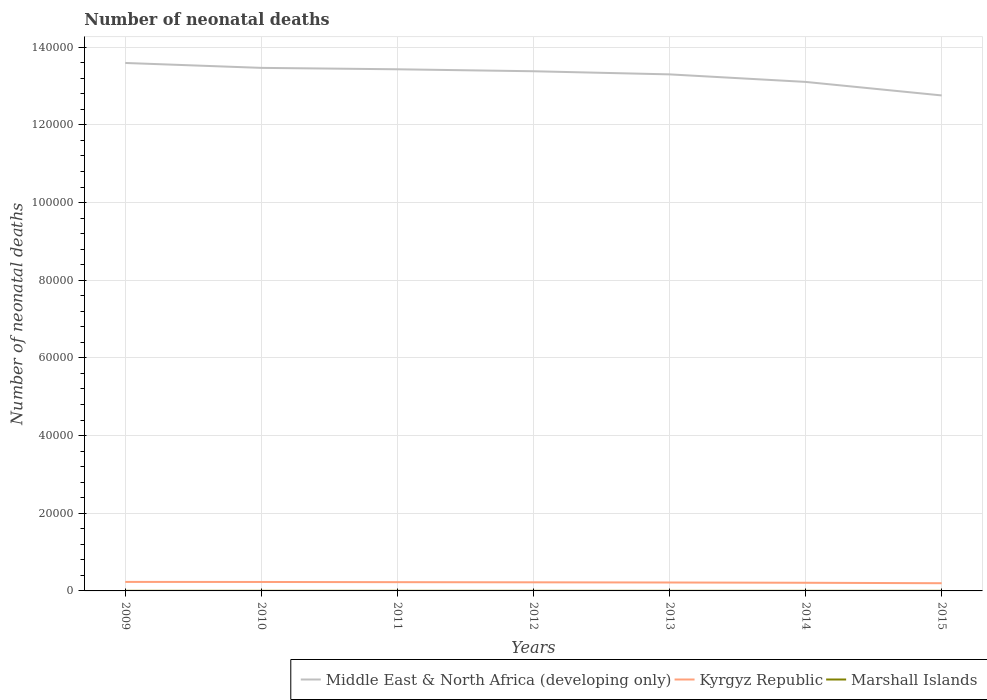In which year was the number of neonatal deaths in in Middle East & North Africa (developing only) maximum?
Ensure brevity in your answer.  2015. What is the total number of neonatal deaths in in Kyrgyz Republic in the graph?
Give a very brief answer. 70. What is the difference between the highest and the second highest number of neonatal deaths in in Kyrgyz Republic?
Your answer should be compact. 337. What is the difference between the highest and the lowest number of neonatal deaths in in Kyrgyz Republic?
Keep it short and to the point. 4. Is the number of neonatal deaths in in Kyrgyz Republic strictly greater than the number of neonatal deaths in in Marshall Islands over the years?
Your answer should be very brief. No. How many years are there in the graph?
Provide a short and direct response. 7. Does the graph contain any zero values?
Your response must be concise. No. Where does the legend appear in the graph?
Ensure brevity in your answer.  Bottom right. How many legend labels are there?
Your answer should be compact. 3. What is the title of the graph?
Make the answer very short. Number of neonatal deaths. What is the label or title of the Y-axis?
Provide a short and direct response. Number of neonatal deaths. What is the Number of neonatal deaths of Middle East & North Africa (developing only) in 2009?
Make the answer very short. 1.36e+05. What is the Number of neonatal deaths of Kyrgyz Republic in 2009?
Provide a succinct answer. 2322. What is the Number of neonatal deaths in Marshall Islands in 2009?
Keep it short and to the point. 29. What is the Number of neonatal deaths of Middle East & North Africa (developing only) in 2010?
Your response must be concise. 1.35e+05. What is the Number of neonatal deaths in Kyrgyz Republic in 2010?
Your answer should be compact. 2306. What is the Number of neonatal deaths of Middle East & North Africa (developing only) in 2011?
Your answer should be compact. 1.34e+05. What is the Number of neonatal deaths in Kyrgyz Republic in 2011?
Provide a short and direct response. 2257. What is the Number of neonatal deaths in Middle East & North Africa (developing only) in 2012?
Keep it short and to the point. 1.34e+05. What is the Number of neonatal deaths in Kyrgyz Republic in 2012?
Provide a short and direct response. 2217. What is the Number of neonatal deaths in Middle East & North Africa (developing only) in 2013?
Your response must be concise. 1.33e+05. What is the Number of neonatal deaths of Kyrgyz Republic in 2013?
Give a very brief answer. 2169. What is the Number of neonatal deaths in Marshall Islands in 2013?
Offer a terse response. 25. What is the Number of neonatal deaths of Middle East & North Africa (developing only) in 2014?
Your answer should be very brief. 1.31e+05. What is the Number of neonatal deaths of Kyrgyz Republic in 2014?
Ensure brevity in your answer.  2099. What is the Number of neonatal deaths in Middle East & North Africa (developing only) in 2015?
Keep it short and to the point. 1.28e+05. What is the Number of neonatal deaths in Kyrgyz Republic in 2015?
Provide a short and direct response. 1985. What is the Number of neonatal deaths in Marshall Islands in 2015?
Your answer should be compact. 23. Across all years, what is the maximum Number of neonatal deaths in Middle East & North Africa (developing only)?
Your response must be concise. 1.36e+05. Across all years, what is the maximum Number of neonatal deaths of Kyrgyz Republic?
Offer a very short reply. 2322. Across all years, what is the minimum Number of neonatal deaths of Middle East & North Africa (developing only)?
Make the answer very short. 1.28e+05. Across all years, what is the minimum Number of neonatal deaths in Kyrgyz Republic?
Keep it short and to the point. 1985. What is the total Number of neonatal deaths of Middle East & North Africa (developing only) in the graph?
Offer a very short reply. 9.30e+05. What is the total Number of neonatal deaths of Kyrgyz Republic in the graph?
Your response must be concise. 1.54e+04. What is the total Number of neonatal deaths of Marshall Islands in the graph?
Offer a very short reply. 182. What is the difference between the Number of neonatal deaths in Middle East & North Africa (developing only) in 2009 and that in 2010?
Make the answer very short. 1262. What is the difference between the Number of neonatal deaths in Kyrgyz Republic in 2009 and that in 2010?
Provide a short and direct response. 16. What is the difference between the Number of neonatal deaths in Middle East & North Africa (developing only) in 2009 and that in 2011?
Offer a terse response. 1625. What is the difference between the Number of neonatal deaths of Kyrgyz Republic in 2009 and that in 2011?
Keep it short and to the point. 65. What is the difference between the Number of neonatal deaths of Middle East & North Africa (developing only) in 2009 and that in 2012?
Offer a very short reply. 2132. What is the difference between the Number of neonatal deaths in Kyrgyz Republic in 2009 and that in 2012?
Ensure brevity in your answer.  105. What is the difference between the Number of neonatal deaths in Middle East & North Africa (developing only) in 2009 and that in 2013?
Keep it short and to the point. 2936. What is the difference between the Number of neonatal deaths in Kyrgyz Republic in 2009 and that in 2013?
Provide a short and direct response. 153. What is the difference between the Number of neonatal deaths of Marshall Islands in 2009 and that in 2013?
Keep it short and to the point. 4. What is the difference between the Number of neonatal deaths in Middle East & North Africa (developing only) in 2009 and that in 2014?
Keep it short and to the point. 4877. What is the difference between the Number of neonatal deaths of Kyrgyz Republic in 2009 and that in 2014?
Your answer should be compact. 223. What is the difference between the Number of neonatal deaths in Middle East & North Africa (developing only) in 2009 and that in 2015?
Your answer should be compact. 8357. What is the difference between the Number of neonatal deaths of Kyrgyz Republic in 2009 and that in 2015?
Give a very brief answer. 337. What is the difference between the Number of neonatal deaths of Marshall Islands in 2009 and that in 2015?
Your answer should be compact. 6. What is the difference between the Number of neonatal deaths in Middle East & North Africa (developing only) in 2010 and that in 2011?
Your response must be concise. 363. What is the difference between the Number of neonatal deaths in Marshall Islands in 2010 and that in 2011?
Your response must be concise. 1. What is the difference between the Number of neonatal deaths of Middle East & North Africa (developing only) in 2010 and that in 2012?
Your answer should be very brief. 870. What is the difference between the Number of neonatal deaths in Kyrgyz Republic in 2010 and that in 2012?
Your answer should be compact. 89. What is the difference between the Number of neonatal deaths of Middle East & North Africa (developing only) in 2010 and that in 2013?
Provide a succinct answer. 1674. What is the difference between the Number of neonatal deaths in Kyrgyz Republic in 2010 and that in 2013?
Your response must be concise. 137. What is the difference between the Number of neonatal deaths of Middle East & North Africa (developing only) in 2010 and that in 2014?
Offer a terse response. 3615. What is the difference between the Number of neonatal deaths of Kyrgyz Republic in 2010 and that in 2014?
Make the answer very short. 207. What is the difference between the Number of neonatal deaths of Marshall Islands in 2010 and that in 2014?
Give a very brief answer. 4. What is the difference between the Number of neonatal deaths in Middle East & North Africa (developing only) in 2010 and that in 2015?
Your response must be concise. 7095. What is the difference between the Number of neonatal deaths in Kyrgyz Republic in 2010 and that in 2015?
Your answer should be compact. 321. What is the difference between the Number of neonatal deaths in Marshall Islands in 2010 and that in 2015?
Offer a terse response. 5. What is the difference between the Number of neonatal deaths of Middle East & North Africa (developing only) in 2011 and that in 2012?
Your response must be concise. 507. What is the difference between the Number of neonatal deaths in Kyrgyz Republic in 2011 and that in 2012?
Provide a short and direct response. 40. What is the difference between the Number of neonatal deaths in Middle East & North Africa (developing only) in 2011 and that in 2013?
Give a very brief answer. 1311. What is the difference between the Number of neonatal deaths of Marshall Islands in 2011 and that in 2013?
Provide a short and direct response. 2. What is the difference between the Number of neonatal deaths in Middle East & North Africa (developing only) in 2011 and that in 2014?
Give a very brief answer. 3252. What is the difference between the Number of neonatal deaths in Kyrgyz Republic in 2011 and that in 2014?
Offer a terse response. 158. What is the difference between the Number of neonatal deaths of Marshall Islands in 2011 and that in 2014?
Provide a short and direct response. 3. What is the difference between the Number of neonatal deaths in Middle East & North Africa (developing only) in 2011 and that in 2015?
Offer a terse response. 6732. What is the difference between the Number of neonatal deaths of Kyrgyz Republic in 2011 and that in 2015?
Your answer should be very brief. 272. What is the difference between the Number of neonatal deaths of Middle East & North Africa (developing only) in 2012 and that in 2013?
Ensure brevity in your answer.  804. What is the difference between the Number of neonatal deaths in Kyrgyz Republic in 2012 and that in 2013?
Your answer should be compact. 48. What is the difference between the Number of neonatal deaths of Marshall Islands in 2012 and that in 2013?
Provide a short and direct response. 1. What is the difference between the Number of neonatal deaths of Middle East & North Africa (developing only) in 2012 and that in 2014?
Ensure brevity in your answer.  2745. What is the difference between the Number of neonatal deaths of Kyrgyz Republic in 2012 and that in 2014?
Your response must be concise. 118. What is the difference between the Number of neonatal deaths of Marshall Islands in 2012 and that in 2014?
Ensure brevity in your answer.  2. What is the difference between the Number of neonatal deaths of Middle East & North Africa (developing only) in 2012 and that in 2015?
Give a very brief answer. 6225. What is the difference between the Number of neonatal deaths in Kyrgyz Republic in 2012 and that in 2015?
Offer a terse response. 232. What is the difference between the Number of neonatal deaths in Middle East & North Africa (developing only) in 2013 and that in 2014?
Offer a very short reply. 1941. What is the difference between the Number of neonatal deaths in Kyrgyz Republic in 2013 and that in 2014?
Keep it short and to the point. 70. What is the difference between the Number of neonatal deaths in Marshall Islands in 2013 and that in 2014?
Give a very brief answer. 1. What is the difference between the Number of neonatal deaths in Middle East & North Africa (developing only) in 2013 and that in 2015?
Provide a succinct answer. 5421. What is the difference between the Number of neonatal deaths in Kyrgyz Republic in 2013 and that in 2015?
Provide a succinct answer. 184. What is the difference between the Number of neonatal deaths in Middle East & North Africa (developing only) in 2014 and that in 2015?
Keep it short and to the point. 3480. What is the difference between the Number of neonatal deaths in Kyrgyz Republic in 2014 and that in 2015?
Your response must be concise. 114. What is the difference between the Number of neonatal deaths in Middle East & North Africa (developing only) in 2009 and the Number of neonatal deaths in Kyrgyz Republic in 2010?
Your response must be concise. 1.34e+05. What is the difference between the Number of neonatal deaths in Middle East & North Africa (developing only) in 2009 and the Number of neonatal deaths in Marshall Islands in 2010?
Give a very brief answer. 1.36e+05. What is the difference between the Number of neonatal deaths in Kyrgyz Republic in 2009 and the Number of neonatal deaths in Marshall Islands in 2010?
Your answer should be very brief. 2294. What is the difference between the Number of neonatal deaths of Middle East & North Africa (developing only) in 2009 and the Number of neonatal deaths of Kyrgyz Republic in 2011?
Your response must be concise. 1.34e+05. What is the difference between the Number of neonatal deaths in Middle East & North Africa (developing only) in 2009 and the Number of neonatal deaths in Marshall Islands in 2011?
Make the answer very short. 1.36e+05. What is the difference between the Number of neonatal deaths of Kyrgyz Republic in 2009 and the Number of neonatal deaths of Marshall Islands in 2011?
Offer a very short reply. 2295. What is the difference between the Number of neonatal deaths of Middle East & North Africa (developing only) in 2009 and the Number of neonatal deaths of Kyrgyz Republic in 2012?
Your answer should be very brief. 1.34e+05. What is the difference between the Number of neonatal deaths of Middle East & North Africa (developing only) in 2009 and the Number of neonatal deaths of Marshall Islands in 2012?
Make the answer very short. 1.36e+05. What is the difference between the Number of neonatal deaths of Kyrgyz Republic in 2009 and the Number of neonatal deaths of Marshall Islands in 2012?
Ensure brevity in your answer.  2296. What is the difference between the Number of neonatal deaths in Middle East & North Africa (developing only) in 2009 and the Number of neonatal deaths in Kyrgyz Republic in 2013?
Offer a very short reply. 1.34e+05. What is the difference between the Number of neonatal deaths of Middle East & North Africa (developing only) in 2009 and the Number of neonatal deaths of Marshall Islands in 2013?
Offer a terse response. 1.36e+05. What is the difference between the Number of neonatal deaths in Kyrgyz Republic in 2009 and the Number of neonatal deaths in Marshall Islands in 2013?
Your response must be concise. 2297. What is the difference between the Number of neonatal deaths of Middle East & North Africa (developing only) in 2009 and the Number of neonatal deaths of Kyrgyz Republic in 2014?
Provide a succinct answer. 1.34e+05. What is the difference between the Number of neonatal deaths in Middle East & North Africa (developing only) in 2009 and the Number of neonatal deaths in Marshall Islands in 2014?
Your answer should be very brief. 1.36e+05. What is the difference between the Number of neonatal deaths in Kyrgyz Republic in 2009 and the Number of neonatal deaths in Marshall Islands in 2014?
Your response must be concise. 2298. What is the difference between the Number of neonatal deaths in Middle East & North Africa (developing only) in 2009 and the Number of neonatal deaths in Kyrgyz Republic in 2015?
Your response must be concise. 1.34e+05. What is the difference between the Number of neonatal deaths of Middle East & North Africa (developing only) in 2009 and the Number of neonatal deaths of Marshall Islands in 2015?
Make the answer very short. 1.36e+05. What is the difference between the Number of neonatal deaths of Kyrgyz Republic in 2009 and the Number of neonatal deaths of Marshall Islands in 2015?
Offer a terse response. 2299. What is the difference between the Number of neonatal deaths in Middle East & North Africa (developing only) in 2010 and the Number of neonatal deaths in Kyrgyz Republic in 2011?
Make the answer very short. 1.32e+05. What is the difference between the Number of neonatal deaths of Middle East & North Africa (developing only) in 2010 and the Number of neonatal deaths of Marshall Islands in 2011?
Offer a very short reply. 1.35e+05. What is the difference between the Number of neonatal deaths of Kyrgyz Republic in 2010 and the Number of neonatal deaths of Marshall Islands in 2011?
Your answer should be compact. 2279. What is the difference between the Number of neonatal deaths in Middle East & North Africa (developing only) in 2010 and the Number of neonatal deaths in Kyrgyz Republic in 2012?
Provide a short and direct response. 1.32e+05. What is the difference between the Number of neonatal deaths of Middle East & North Africa (developing only) in 2010 and the Number of neonatal deaths of Marshall Islands in 2012?
Ensure brevity in your answer.  1.35e+05. What is the difference between the Number of neonatal deaths of Kyrgyz Republic in 2010 and the Number of neonatal deaths of Marshall Islands in 2012?
Keep it short and to the point. 2280. What is the difference between the Number of neonatal deaths in Middle East & North Africa (developing only) in 2010 and the Number of neonatal deaths in Kyrgyz Republic in 2013?
Give a very brief answer. 1.33e+05. What is the difference between the Number of neonatal deaths of Middle East & North Africa (developing only) in 2010 and the Number of neonatal deaths of Marshall Islands in 2013?
Your answer should be very brief. 1.35e+05. What is the difference between the Number of neonatal deaths of Kyrgyz Republic in 2010 and the Number of neonatal deaths of Marshall Islands in 2013?
Ensure brevity in your answer.  2281. What is the difference between the Number of neonatal deaths in Middle East & North Africa (developing only) in 2010 and the Number of neonatal deaths in Kyrgyz Republic in 2014?
Keep it short and to the point. 1.33e+05. What is the difference between the Number of neonatal deaths of Middle East & North Africa (developing only) in 2010 and the Number of neonatal deaths of Marshall Islands in 2014?
Offer a terse response. 1.35e+05. What is the difference between the Number of neonatal deaths of Kyrgyz Republic in 2010 and the Number of neonatal deaths of Marshall Islands in 2014?
Provide a short and direct response. 2282. What is the difference between the Number of neonatal deaths of Middle East & North Africa (developing only) in 2010 and the Number of neonatal deaths of Kyrgyz Republic in 2015?
Your response must be concise. 1.33e+05. What is the difference between the Number of neonatal deaths in Middle East & North Africa (developing only) in 2010 and the Number of neonatal deaths in Marshall Islands in 2015?
Your response must be concise. 1.35e+05. What is the difference between the Number of neonatal deaths in Kyrgyz Republic in 2010 and the Number of neonatal deaths in Marshall Islands in 2015?
Ensure brevity in your answer.  2283. What is the difference between the Number of neonatal deaths of Middle East & North Africa (developing only) in 2011 and the Number of neonatal deaths of Kyrgyz Republic in 2012?
Your response must be concise. 1.32e+05. What is the difference between the Number of neonatal deaths of Middle East & North Africa (developing only) in 2011 and the Number of neonatal deaths of Marshall Islands in 2012?
Ensure brevity in your answer.  1.34e+05. What is the difference between the Number of neonatal deaths in Kyrgyz Republic in 2011 and the Number of neonatal deaths in Marshall Islands in 2012?
Offer a very short reply. 2231. What is the difference between the Number of neonatal deaths in Middle East & North Africa (developing only) in 2011 and the Number of neonatal deaths in Kyrgyz Republic in 2013?
Give a very brief answer. 1.32e+05. What is the difference between the Number of neonatal deaths of Middle East & North Africa (developing only) in 2011 and the Number of neonatal deaths of Marshall Islands in 2013?
Your answer should be compact. 1.34e+05. What is the difference between the Number of neonatal deaths in Kyrgyz Republic in 2011 and the Number of neonatal deaths in Marshall Islands in 2013?
Offer a terse response. 2232. What is the difference between the Number of neonatal deaths of Middle East & North Africa (developing only) in 2011 and the Number of neonatal deaths of Kyrgyz Republic in 2014?
Offer a very short reply. 1.32e+05. What is the difference between the Number of neonatal deaths in Middle East & North Africa (developing only) in 2011 and the Number of neonatal deaths in Marshall Islands in 2014?
Keep it short and to the point. 1.34e+05. What is the difference between the Number of neonatal deaths of Kyrgyz Republic in 2011 and the Number of neonatal deaths of Marshall Islands in 2014?
Offer a terse response. 2233. What is the difference between the Number of neonatal deaths in Middle East & North Africa (developing only) in 2011 and the Number of neonatal deaths in Kyrgyz Republic in 2015?
Ensure brevity in your answer.  1.32e+05. What is the difference between the Number of neonatal deaths of Middle East & North Africa (developing only) in 2011 and the Number of neonatal deaths of Marshall Islands in 2015?
Ensure brevity in your answer.  1.34e+05. What is the difference between the Number of neonatal deaths in Kyrgyz Republic in 2011 and the Number of neonatal deaths in Marshall Islands in 2015?
Your response must be concise. 2234. What is the difference between the Number of neonatal deaths in Middle East & North Africa (developing only) in 2012 and the Number of neonatal deaths in Kyrgyz Republic in 2013?
Keep it short and to the point. 1.32e+05. What is the difference between the Number of neonatal deaths in Middle East & North Africa (developing only) in 2012 and the Number of neonatal deaths in Marshall Islands in 2013?
Offer a terse response. 1.34e+05. What is the difference between the Number of neonatal deaths in Kyrgyz Republic in 2012 and the Number of neonatal deaths in Marshall Islands in 2013?
Offer a very short reply. 2192. What is the difference between the Number of neonatal deaths of Middle East & North Africa (developing only) in 2012 and the Number of neonatal deaths of Kyrgyz Republic in 2014?
Your response must be concise. 1.32e+05. What is the difference between the Number of neonatal deaths in Middle East & North Africa (developing only) in 2012 and the Number of neonatal deaths in Marshall Islands in 2014?
Your response must be concise. 1.34e+05. What is the difference between the Number of neonatal deaths of Kyrgyz Republic in 2012 and the Number of neonatal deaths of Marshall Islands in 2014?
Your answer should be compact. 2193. What is the difference between the Number of neonatal deaths in Middle East & North Africa (developing only) in 2012 and the Number of neonatal deaths in Kyrgyz Republic in 2015?
Your response must be concise. 1.32e+05. What is the difference between the Number of neonatal deaths of Middle East & North Africa (developing only) in 2012 and the Number of neonatal deaths of Marshall Islands in 2015?
Your answer should be very brief. 1.34e+05. What is the difference between the Number of neonatal deaths in Kyrgyz Republic in 2012 and the Number of neonatal deaths in Marshall Islands in 2015?
Keep it short and to the point. 2194. What is the difference between the Number of neonatal deaths of Middle East & North Africa (developing only) in 2013 and the Number of neonatal deaths of Kyrgyz Republic in 2014?
Ensure brevity in your answer.  1.31e+05. What is the difference between the Number of neonatal deaths in Middle East & North Africa (developing only) in 2013 and the Number of neonatal deaths in Marshall Islands in 2014?
Your answer should be compact. 1.33e+05. What is the difference between the Number of neonatal deaths in Kyrgyz Republic in 2013 and the Number of neonatal deaths in Marshall Islands in 2014?
Keep it short and to the point. 2145. What is the difference between the Number of neonatal deaths in Middle East & North Africa (developing only) in 2013 and the Number of neonatal deaths in Kyrgyz Republic in 2015?
Offer a very short reply. 1.31e+05. What is the difference between the Number of neonatal deaths in Middle East & North Africa (developing only) in 2013 and the Number of neonatal deaths in Marshall Islands in 2015?
Make the answer very short. 1.33e+05. What is the difference between the Number of neonatal deaths in Kyrgyz Republic in 2013 and the Number of neonatal deaths in Marshall Islands in 2015?
Provide a short and direct response. 2146. What is the difference between the Number of neonatal deaths of Middle East & North Africa (developing only) in 2014 and the Number of neonatal deaths of Kyrgyz Republic in 2015?
Your answer should be compact. 1.29e+05. What is the difference between the Number of neonatal deaths of Middle East & North Africa (developing only) in 2014 and the Number of neonatal deaths of Marshall Islands in 2015?
Offer a very short reply. 1.31e+05. What is the difference between the Number of neonatal deaths in Kyrgyz Republic in 2014 and the Number of neonatal deaths in Marshall Islands in 2015?
Provide a succinct answer. 2076. What is the average Number of neonatal deaths of Middle East & North Africa (developing only) per year?
Provide a succinct answer. 1.33e+05. What is the average Number of neonatal deaths of Kyrgyz Republic per year?
Provide a succinct answer. 2193.57. In the year 2009, what is the difference between the Number of neonatal deaths in Middle East & North Africa (developing only) and Number of neonatal deaths in Kyrgyz Republic?
Give a very brief answer. 1.34e+05. In the year 2009, what is the difference between the Number of neonatal deaths in Middle East & North Africa (developing only) and Number of neonatal deaths in Marshall Islands?
Keep it short and to the point. 1.36e+05. In the year 2009, what is the difference between the Number of neonatal deaths of Kyrgyz Republic and Number of neonatal deaths of Marshall Islands?
Give a very brief answer. 2293. In the year 2010, what is the difference between the Number of neonatal deaths of Middle East & North Africa (developing only) and Number of neonatal deaths of Kyrgyz Republic?
Give a very brief answer. 1.32e+05. In the year 2010, what is the difference between the Number of neonatal deaths of Middle East & North Africa (developing only) and Number of neonatal deaths of Marshall Islands?
Make the answer very short. 1.35e+05. In the year 2010, what is the difference between the Number of neonatal deaths of Kyrgyz Republic and Number of neonatal deaths of Marshall Islands?
Your response must be concise. 2278. In the year 2011, what is the difference between the Number of neonatal deaths in Middle East & North Africa (developing only) and Number of neonatal deaths in Kyrgyz Republic?
Provide a succinct answer. 1.32e+05. In the year 2011, what is the difference between the Number of neonatal deaths of Middle East & North Africa (developing only) and Number of neonatal deaths of Marshall Islands?
Make the answer very short. 1.34e+05. In the year 2011, what is the difference between the Number of neonatal deaths of Kyrgyz Republic and Number of neonatal deaths of Marshall Islands?
Offer a terse response. 2230. In the year 2012, what is the difference between the Number of neonatal deaths in Middle East & North Africa (developing only) and Number of neonatal deaths in Kyrgyz Republic?
Ensure brevity in your answer.  1.32e+05. In the year 2012, what is the difference between the Number of neonatal deaths of Middle East & North Africa (developing only) and Number of neonatal deaths of Marshall Islands?
Give a very brief answer. 1.34e+05. In the year 2012, what is the difference between the Number of neonatal deaths of Kyrgyz Republic and Number of neonatal deaths of Marshall Islands?
Provide a short and direct response. 2191. In the year 2013, what is the difference between the Number of neonatal deaths of Middle East & North Africa (developing only) and Number of neonatal deaths of Kyrgyz Republic?
Your answer should be compact. 1.31e+05. In the year 2013, what is the difference between the Number of neonatal deaths in Middle East & North Africa (developing only) and Number of neonatal deaths in Marshall Islands?
Keep it short and to the point. 1.33e+05. In the year 2013, what is the difference between the Number of neonatal deaths of Kyrgyz Republic and Number of neonatal deaths of Marshall Islands?
Ensure brevity in your answer.  2144. In the year 2014, what is the difference between the Number of neonatal deaths in Middle East & North Africa (developing only) and Number of neonatal deaths in Kyrgyz Republic?
Provide a short and direct response. 1.29e+05. In the year 2014, what is the difference between the Number of neonatal deaths in Middle East & North Africa (developing only) and Number of neonatal deaths in Marshall Islands?
Provide a succinct answer. 1.31e+05. In the year 2014, what is the difference between the Number of neonatal deaths of Kyrgyz Republic and Number of neonatal deaths of Marshall Islands?
Provide a short and direct response. 2075. In the year 2015, what is the difference between the Number of neonatal deaths in Middle East & North Africa (developing only) and Number of neonatal deaths in Kyrgyz Republic?
Make the answer very short. 1.26e+05. In the year 2015, what is the difference between the Number of neonatal deaths in Middle East & North Africa (developing only) and Number of neonatal deaths in Marshall Islands?
Provide a succinct answer. 1.28e+05. In the year 2015, what is the difference between the Number of neonatal deaths of Kyrgyz Republic and Number of neonatal deaths of Marshall Islands?
Provide a short and direct response. 1962. What is the ratio of the Number of neonatal deaths in Middle East & North Africa (developing only) in 2009 to that in 2010?
Provide a succinct answer. 1.01. What is the ratio of the Number of neonatal deaths of Marshall Islands in 2009 to that in 2010?
Offer a very short reply. 1.04. What is the ratio of the Number of neonatal deaths in Middle East & North Africa (developing only) in 2009 to that in 2011?
Make the answer very short. 1.01. What is the ratio of the Number of neonatal deaths in Kyrgyz Republic in 2009 to that in 2011?
Offer a terse response. 1.03. What is the ratio of the Number of neonatal deaths in Marshall Islands in 2009 to that in 2011?
Your response must be concise. 1.07. What is the ratio of the Number of neonatal deaths in Middle East & North Africa (developing only) in 2009 to that in 2012?
Keep it short and to the point. 1.02. What is the ratio of the Number of neonatal deaths of Kyrgyz Republic in 2009 to that in 2012?
Keep it short and to the point. 1.05. What is the ratio of the Number of neonatal deaths in Marshall Islands in 2009 to that in 2012?
Make the answer very short. 1.12. What is the ratio of the Number of neonatal deaths in Middle East & North Africa (developing only) in 2009 to that in 2013?
Give a very brief answer. 1.02. What is the ratio of the Number of neonatal deaths in Kyrgyz Republic in 2009 to that in 2013?
Provide a short and direct response. 1.07. What is the ratio of the Number of neonatal deaths in Marshall Islands in 2009 to that in 2013?
Your answer should be compact. 1.16. What is the ratio of the Number of neonatal deaths of Middle East & North Africa (developing only) in 2009 to that in 2014?
Keep it short and to the point. 1.04. What is the ratio of the Number of neonatal deaths in Kyrgyz Republic in 2009 to that in 2014?
Your response must be concise. 1.11. What is the ratio of the Number of neonatal deaths in Marshall Islands in 2009 to that in 2014?
Give a very brief answer. 1.21. What is the ratio of the Number of neonatal deaths in Middle East & North Africa (developing only) in 2009 to that in 2015?
Provide a short and direct response. 1.07. What is the ratio of the Number of neonatal deaths in Kyrgyz Republic in 2009 to that in 2015?
Give a very brief answer. 1.17. What is the ratio of the Number of neonatal deaths in Marshall Islands in 2009 to that in 2015?
Ensure brevity in your answer.  1.26. What is the ratio of the Number of neonatal deaths of Middle East & North Africa (developing only) in 2010 to that in 2011?
Your response must be concise. 1. What is the ratio of the Number of neonatal deaths in Kyrgyz Republic in 2010 to that in 2011?
Make the answer very short. 1.02. What is the ratio of the Number of neonatal deaths in Kyrgyz Republic in 2010 to that in 2012?
Offer a very short reply. 1.04. What is the ratio of the Number of neonatal deaths of Marshall Islands in 2010 to that in 2012?
Make the answer very short. 1.08. What is the ratio of the Number of neonatal deaths in Middle East & North Africa (developing only) in 2010 to that in 2013?
Your response must be concise. 1.01. What is the ratio of the Number of neonatal deaths in Kyrgyz Republic in 2010 to that in 2013?
Give a very brief answer. 1.06. What is the ratio of the Number of neonatal deaths in Marshall Islands in 2010 to that in 2013?
Ensure brevity in your answer.  1.12. What is the ratio of the Number of neonatal deaths of Middle East & North Africa (developing only) in 2010 to that in 2014?
Offer a terse response. 1.03. What is the ratio of the Number of neonatal deaths in Kyrgyz Republic in 2010 to that in 2014?
Make the answer very short. 1.1. What is the ratio of the Number of neonatal deaths in Middle East & North Africa (developing only) in 2010 to that in 2015?
Provide a short and direct response. 1.06. What is the ratio of the Number of neonatal deaths in Kyrgyz Republic in 2010 to that in 2015?
Ensure brevity in your answer.  1.16. What is the ratio of the Number of neonatal deaths of Marshall Islands in 2010 to that in 2015?
Provide a short and direct response. 1.22. What is the ratio of the Number of neonatal deaths of Middle East & North Africa (developing only) in 2011 to that in 2012?
Give a very brief answer. 1. What is the ratio of the Number of neonatal deaths in Kyrgyz Republic in 2011 to that in 2012?
Offer a terse response. 1.02. What is the ratio of the Number of neonatal deaths in Middle East & North Africa (developing only) in 2011 to that in 2013?
Ensure brevity in your answer.  1.01. What is the ratio of the Number of neonatal deaths in Kyrgyz Republic in 2011 to that in 2013?
Ensure brevity in your answer.  1.04. What is the ratio of the Number of neonatal deaths in Middle East & North Africa (developing only) in 2011 to that in 2014?
Provide a short and direct response. 1.02. What is the ratio of the Number of neonatal deaths of Kyrgyz Republic in 2011 to that in 2014?
Offer a very short reply. 1.08. What is the ratio of the Number of neonatal deaths in Marshall Islands in 2011 to that in 2014?
Give a very brief answer. 1.12. What is the ratio of the Number of neonatal deaths in Middle East & North Africa (developing only) in 2011 to that in 2015?
Give a very brief answer. 1.05. What is the ratio of the Number of neonatal deaths of Kyrgyz Republic in 2011 to that in 2015?
Offer a terse response. 1.14. What is the ratio of the Number of neonatal deaths in Marshall Islands in 2011 to that in 2015?
Offer a very short reply. 1.17. What is the ratio of the Number of neonatal deaths in Middle East & North Africa (developing only) in 2012 to that in 2013?
Provide a succinct answer. 1.01. What is the ratio of the Number of neonatal deaths in Kyrgyz Republic in 2012 to that in 2013?
Offer a very short reply. 1.02. What is the ratio of the Number of neonatal deaths of Middle East & North Africa (developing only) in 2012 to that in 2014?
Your response must be concise. 1.02. What is the ratio of the Number of neonatal deaths in Kyrgyz Republic in 2012 to that in 2014?
Your response must be concise. 1.06. What is the ratio of the Number of neonatal deaths of Middle East & North Africa (developing only) in 2012 to that in 2015?
Your answer should be very brief. 1.05. What is the ratio of the Number of neonatal deaths in Kyrgyz Republic in 2012 to that in 2015?
Make the answer very short. 1.12. What is the ratio of the Number of neonatal deaths of Marshall Islands in 2012 to that in 2015?
Provide a short and direct response. 1.13. What is the ratio of the Number of neonatal deaths of Middle East & North Africa (developing only) in 2013 to that in 2014?
Provide a short and direct response. 1.01. What is the ratio of the Number of neonatal deaths in Marshall Islands in 2013 to that in 2014?
Offer a terse response. 1.04. What is the ratio of the Number of neonatal deaths in Middle East & North Africa (developing only) in 2013 to that in 2015?
Offer a terse response. 1.04. What is the ratio of the Number of neonatal deaths of Kyrgyz Republic in 2013 to that in 2015?
Offer a terse response. 1.09. What is the ratio of the Number of neonatal deaths of Marshall Islands in 2013 to that in 2015?
Your answer should be compact. 1.09. What is the ratio of the Number of neonatal deaths in Middle East & North Africa (developing only) in 2014 to that in 2015?
Your answer should be compact. 1.03. What is the ratio of the Number of neonatal deaths of Kyrgyz Republic in 2014 to that in 2015?
Offer a terse response. 1.06. What is the ratio of the Number of neonatal deaths of Marshall Islands in 2014 to that in 2015?
Provide a succinct answer. 1.04. What is the difference between the highest and the second highest Number of neonatal deaths in Middle East & North Africa (developing only)?
Your response must be concise. 1262. What is the difference between the highest and the second highest Number of neonatal deaths in Marshall Islands?
Offer a terse response. 1. What is the difference between the highest and the lowest Number of neonatal deaths of Middle East & North Africa (developing only)?
Provide a short and direct response. 8357. What is the difference between the highest and the lowest Number of neonatal deaths in Kyrgyz Republic?
Provide a short and direct response. 337. What is the difference between the highest and the lowest Number of neonatal deaths in Marshall Islands?
Keep it short and to the point. 6. 